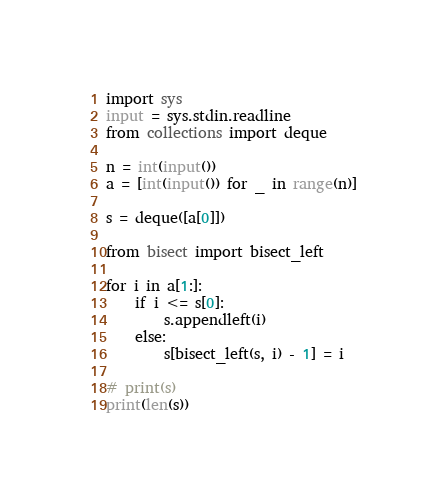<code> <loc_0><loc_0><loc_500><loc_500><_Python_>import sys
input = sys.stdin.readline
from collections import deque

n = int(input())
a = [int(input()) for _ in range(n)]

s = deque([a[0]])

from bisect import bisect_left

for i in a[1:]:
    if i <= s[0]:
        s.appendleft(i)
    else:
        s[bisect_left(s, i) - 1] = i

# print(s)
print(len(s))
</code> 